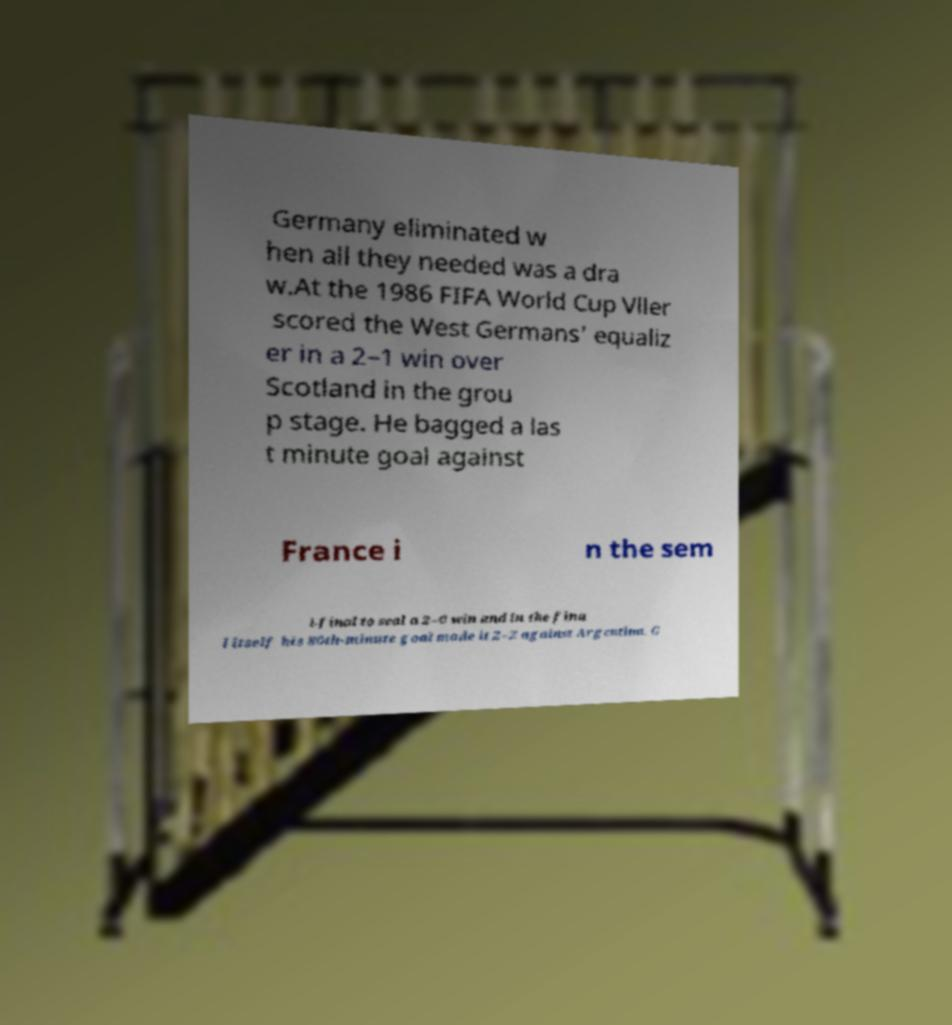Could you extract and type out the text from this image? Germany eliminated w hen all they needed was a dra w.At the 1986 FIFA World Cup Vller scored the West Germans' equaliz er in a 2–1 win over Scotland in the grou p stage. He bagged a las t minute goal against France i n the sem i-final to seal a 2–0 win and in the fina l itself his 80th-minute goal made it 2–2 against Argentina. G 